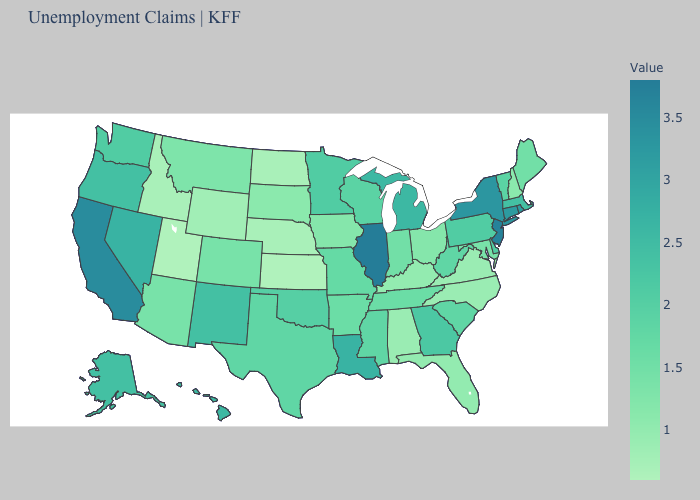Does California have the highest value in the West?
Answer briefly. Yes. Among the states that border Florida , does Georgia have the lowest value?
Quick response, please. No. Is the legend a continuous bar?
Give a very brief answer. Yes. Does Michigan have a lower value than Virginia?
Answer briefly. No. Does Illinois have the highest value in the MidWest?
Answer briefly. Yes. Among the states that border Delaware , which have the highest value?
Be succinct. New Jersey. 